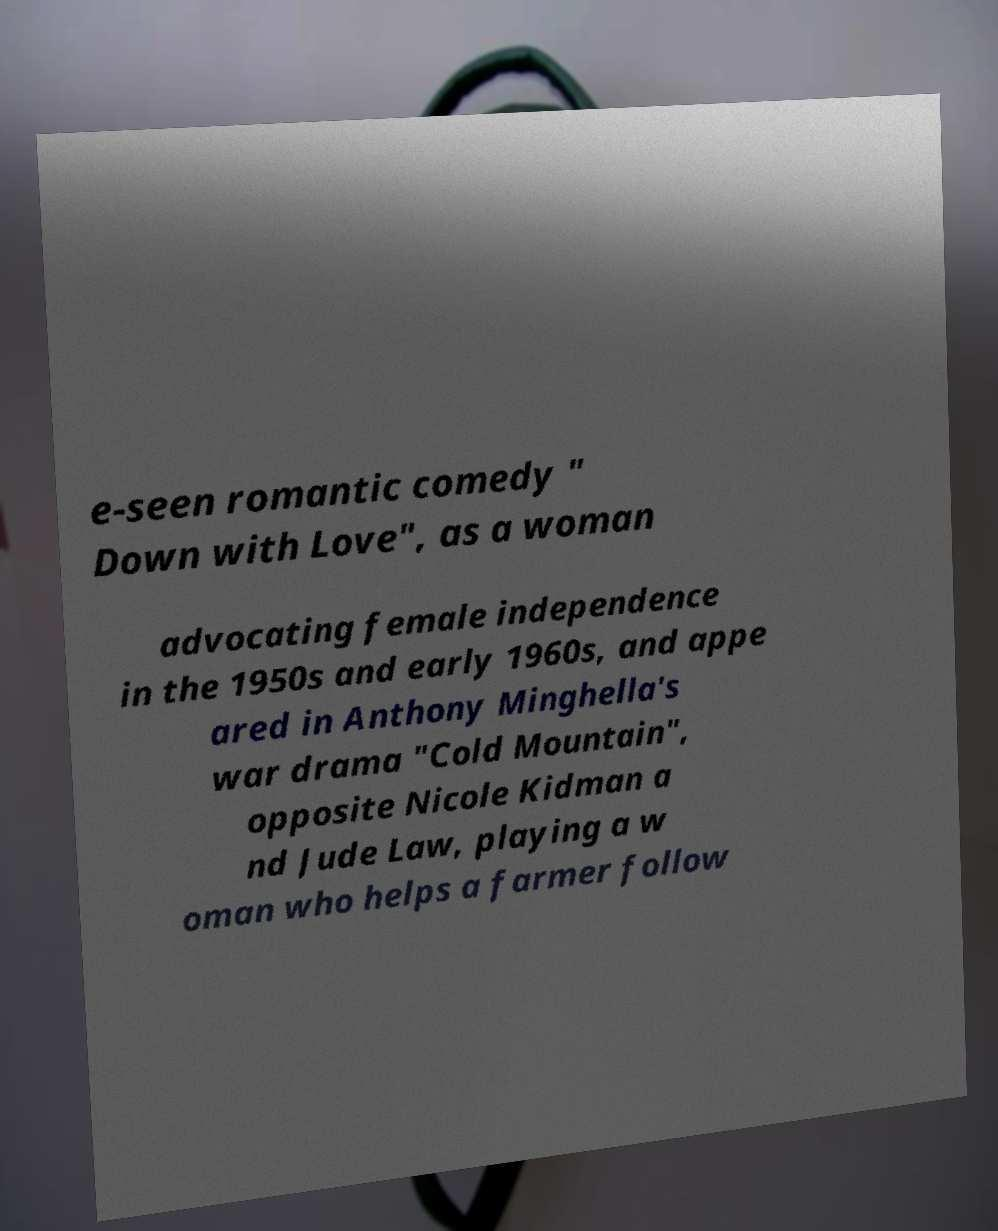Could you extract and type out the text from this image? e-seen romantic comedy " Down with Love", as a woman advocating female independence in the 1950s and early 1960s, and appe ared in Anthony Minghella's war drama "Cold Mountain", opposite Nicole Kidman a nd Jude Law, playing a w oman who helps a farmer follow 